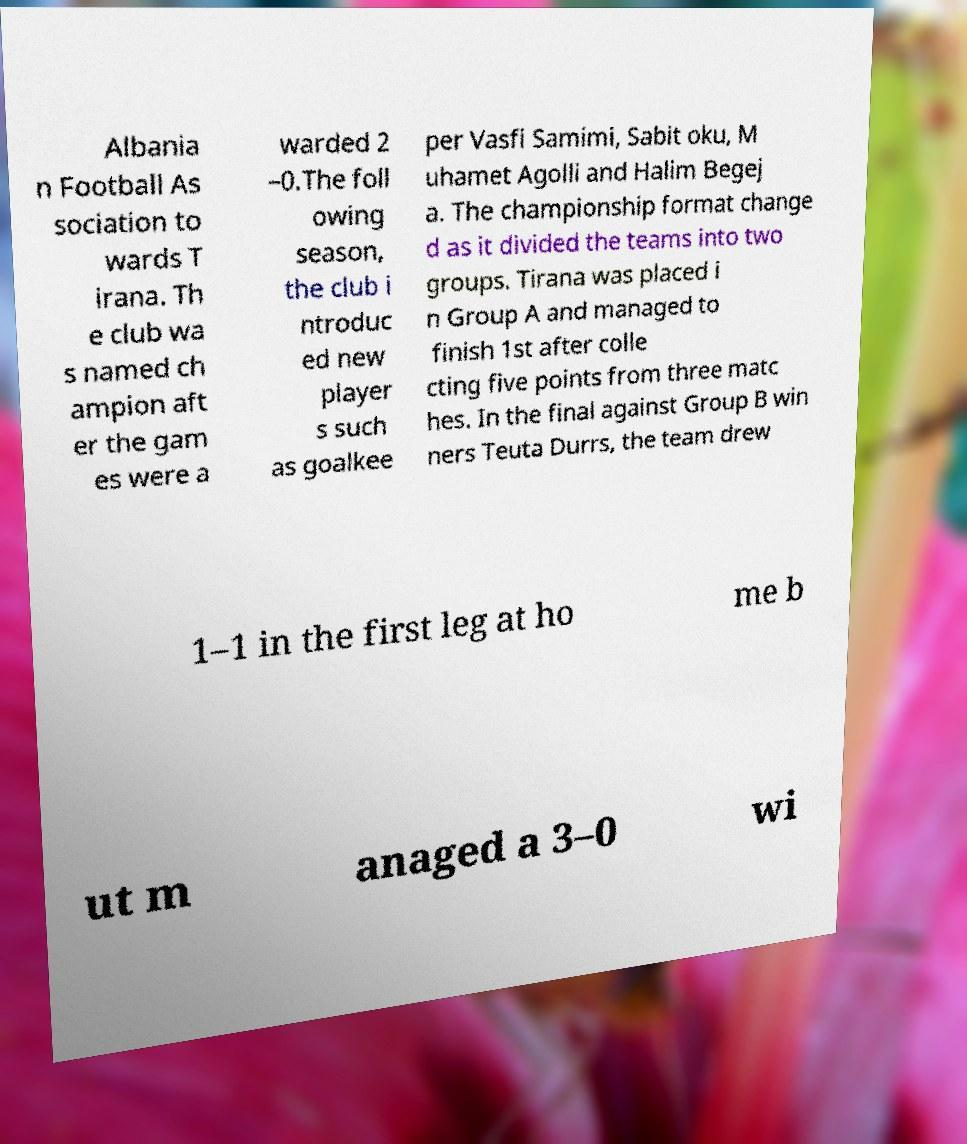Please identify and transcribe the text found in this image. Albania n Football As sociation to wards T irana. Th e club wa s named ch ampion aft er the gam es were a warded 2 –0.The foll owing season, the club i ntroduc ed new player s such as goalkee per Vasfi Samimi, Sabit oku, M uhamet Agolli and Halim Begej a. The championship format change d as it divided the teams into two groups. Tirana was placed i n Group A and managed to finish 1st after colle cting five points from three matc hes. In the final against Group B win ners Teuta Durrs, the team drew 1–1 in the first leg at ho me b ut m anaged a 3–0 wi 